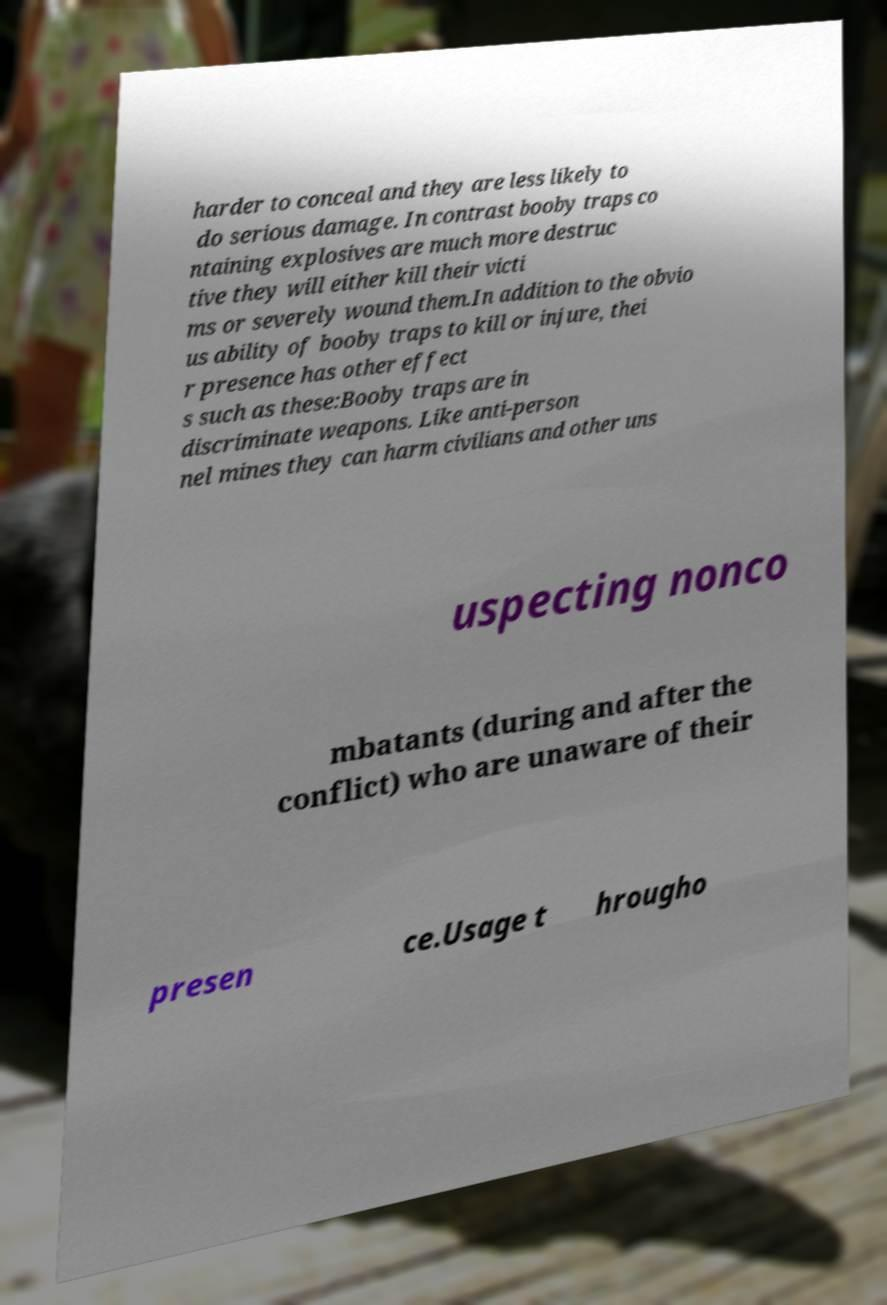Could you extract and type out the text from this image? harder to conceal and they are less likely to do serious damage. In contrast booby traps co ntaining explosives are much more destruc tive they will either kill their victi ms or severely wound them.In addition to the obvio us ability of booby traps to kill or injure, thei r presence has other effect s such as these:Booby traps are in discriminate weapons. Like anti-person nel mines they can harm civilians and other uns uspecting nonco mbatants (during and after the conflict) who are unaware of their presen ce.Usage t hrougho 